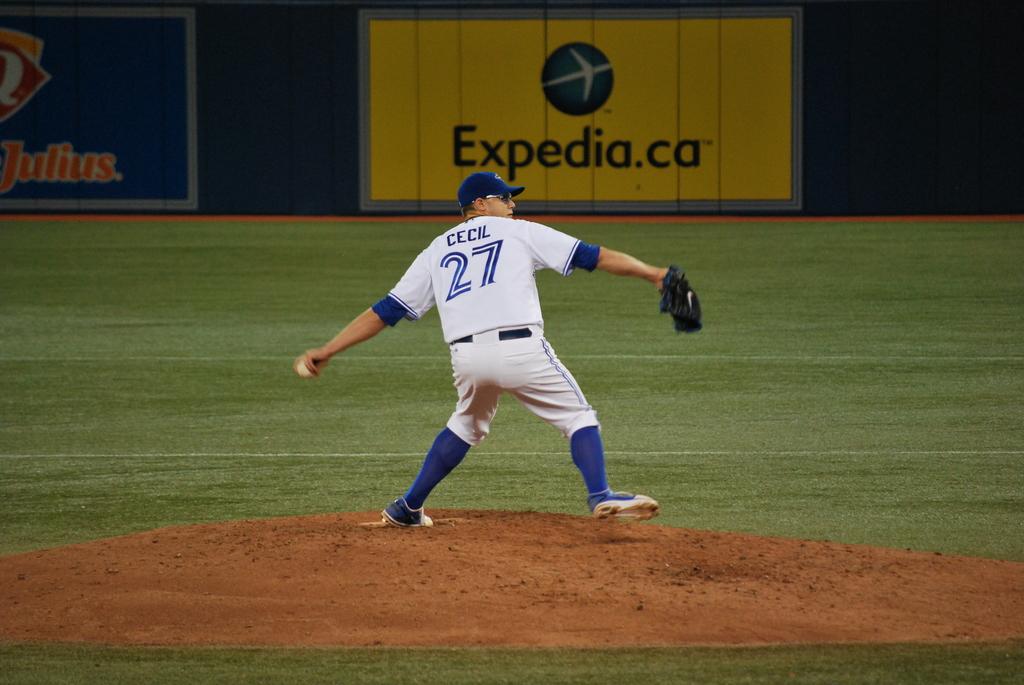What is the website advertised?
Provide a succinct answer. Expedia.ca. 